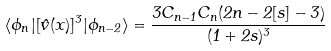Convert formula to latex. <formula><loc_0><loc_0><loc_500><loc_500>\langle \phi _ { n } | [ \hat { v } ( x ) ] ^ { 3 } | \phi _ { n - 2 } \rangle = \frac { 3 C _ { n - 1 } C _ { n } ( 2 n - 2 [ s ] - 3 ) } { ( 1 + 2 s ) ^ { 3 } }</formula> 